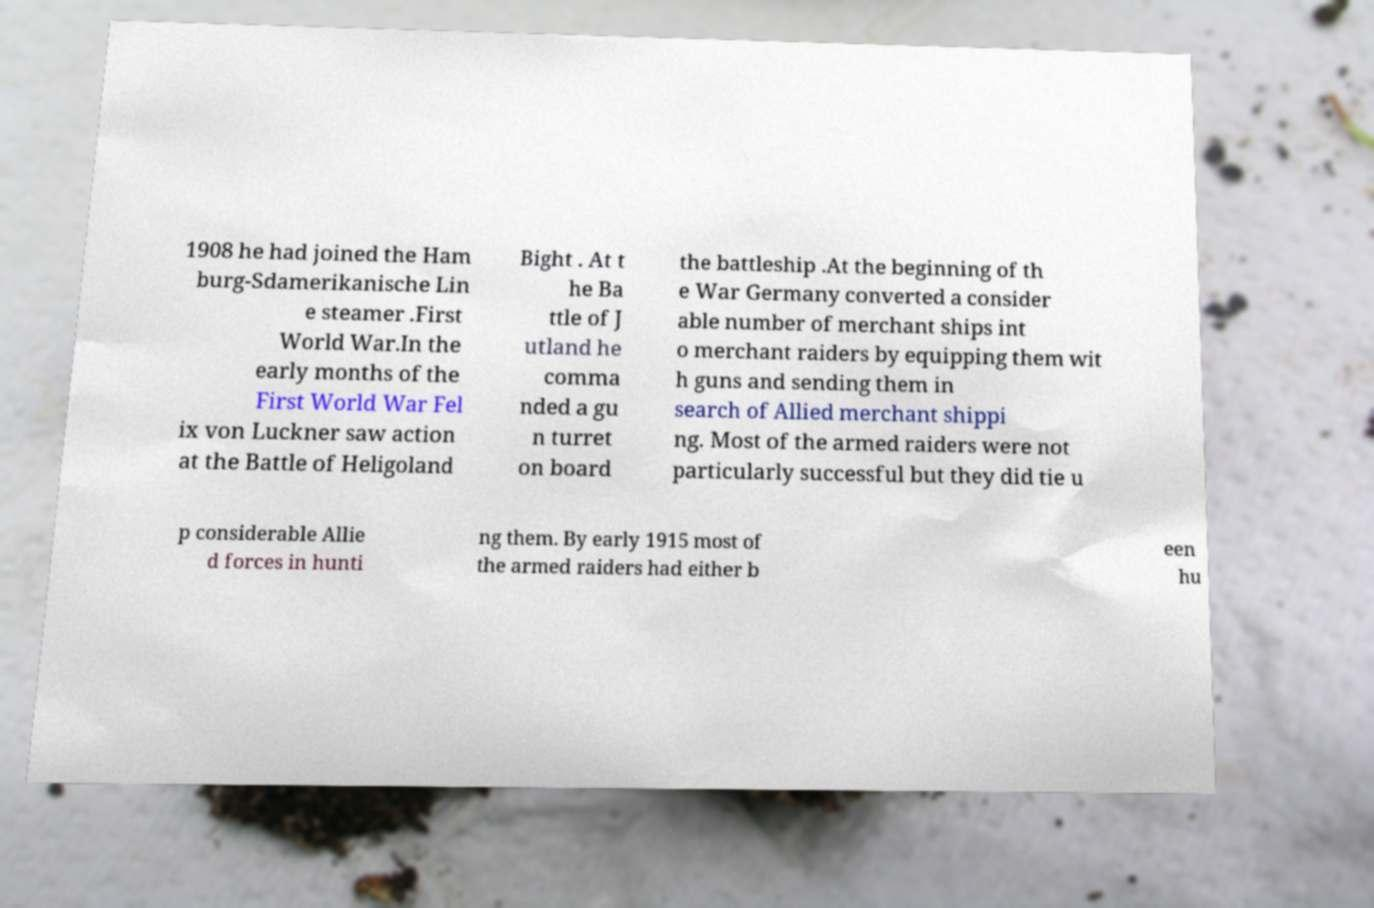What messages or text are displayed in this image? I need them in a readable, typed format. 1908 he had joined the Ham burg-Sdamerikanische Lin e steamer .First World War.In the early months of the First World War Fel ix von Luckner saw action at the Battle of Heligoland Bight . At t he Ba ttle of J utland he comma nded a gu n turret on board the battleship .At the beginning of th e War Germany converted a consider able number of merchant ships int o merchant raiders by equipping them wit h guns and sending them in search of Allied merchant shippi ng. Most of the armed raiders were not particularly successful but they did tie u p considerable Allie d forces in hunti ng them. By early 1915 most of the armed raiders had either b een hu 